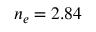Convert formula to latex. <formula><loc_0><loc_0><loc_500><loc_500>n _ { e } = 2 . 8 4</formula> 